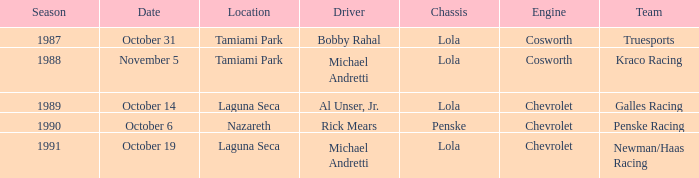Could you parse the entire table as a dict? {'header': ['Season', 'Date', 'Location', 'Driver', 'Chassis', 'Engine', 'Team'], 'rows': [['1987', 'October 31', 'Tamiami Park', 'Bobby Rahal', 'Lola', 'Cosworth', 'Truesports'], ['1988', 'November 5', 'Tamiami Park', 'Michael Andretti', 'Lola', 'Cosworth', 'Kraco Racing'], ['1989', 'October 14', 'Laguna Seca', 'Al Unser, Jr.', 'Lola', 'Chevrolet', 'Galles Racing'], ['1990', 'October 6', 'Nazareth', 'Rick Mears', 'Penske', 'Chevrolet', 'Penske Racing'], ['1991', 'October 19', 'Laguna Seca', 'Michael Andretti', 'Lola', 'Chevrolet', 'Newman/Haas Racing']]} Which team was involved in the race on the 19th of october? Newman/Haas Racing. 